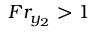<formula> <loc_0><loc_0><loc_500><loc_500>F r _ { y _ { 2 } } > 1</formula> 